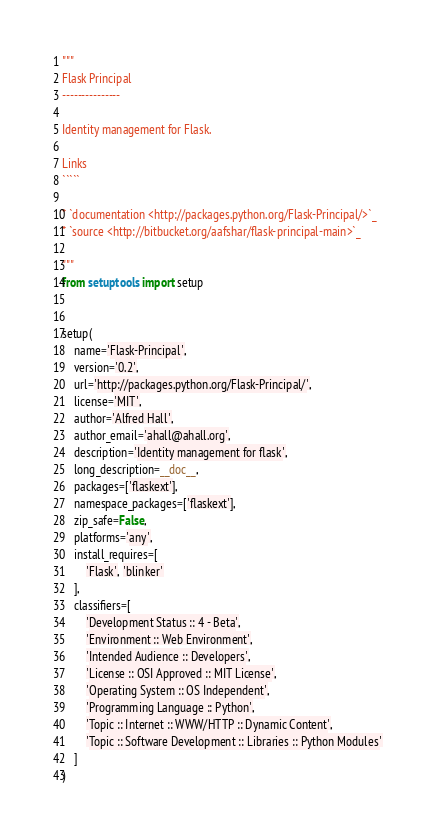Convert code to text. <code><loc_0><loc_0><loc_500><loc_500><_Python_>"""
Flask Principal
---------------

Identity management for Flask.

Links
`````

* `documentation <http://packages.python.org/Flask-Principal/>`_
* `source <http://bitbucket.org/aafshar/flask-principal-main>`_

"""
from setuptools import setup


setup(
    name='Flask-Principal',
    version='0.2',
    url='http://packages.python.org/Flask-Principal/',
    license='MIT',
    author='Alfred Hall',
    author_email='ahall@ahall.org',
    description='Identity management for flask',
    long_description=__doc__,
    packages=['flaskext'],
    namespace_packages=['flaskext'],
    zip_safe=False,
    platforms='any',
    install_requires=[
        'Flask', 'blinker'
    ],
    classifiers=[
        'Development Status :: 4 - Beta',
        'Environment :: Web Environment',
        'Intended Audience :: Developers',
        'License :: OSI Approved :: MIT License',
        'Operating System :: OS Independent',
        'Programming Language :: Python',
        'Topic :: Internet :: WWW/HTTP :: Dynamic Content',
        'Topic :: Software Development :: Libraries :: Python Modules'
    ]
)
</code> 